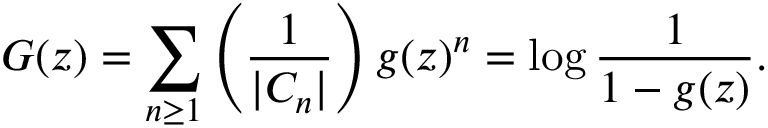<formula> <loc_0><loc_0><loc_500><loc_500>G ( z ) = \sum _ { n \geq 1 } \left ( { \frac { 1 } { | C _ { n } | } } \right ) g ( z ) ^ { n } = \log { \frac { 1 } { 1 - g ( z ) } } .</formula> 